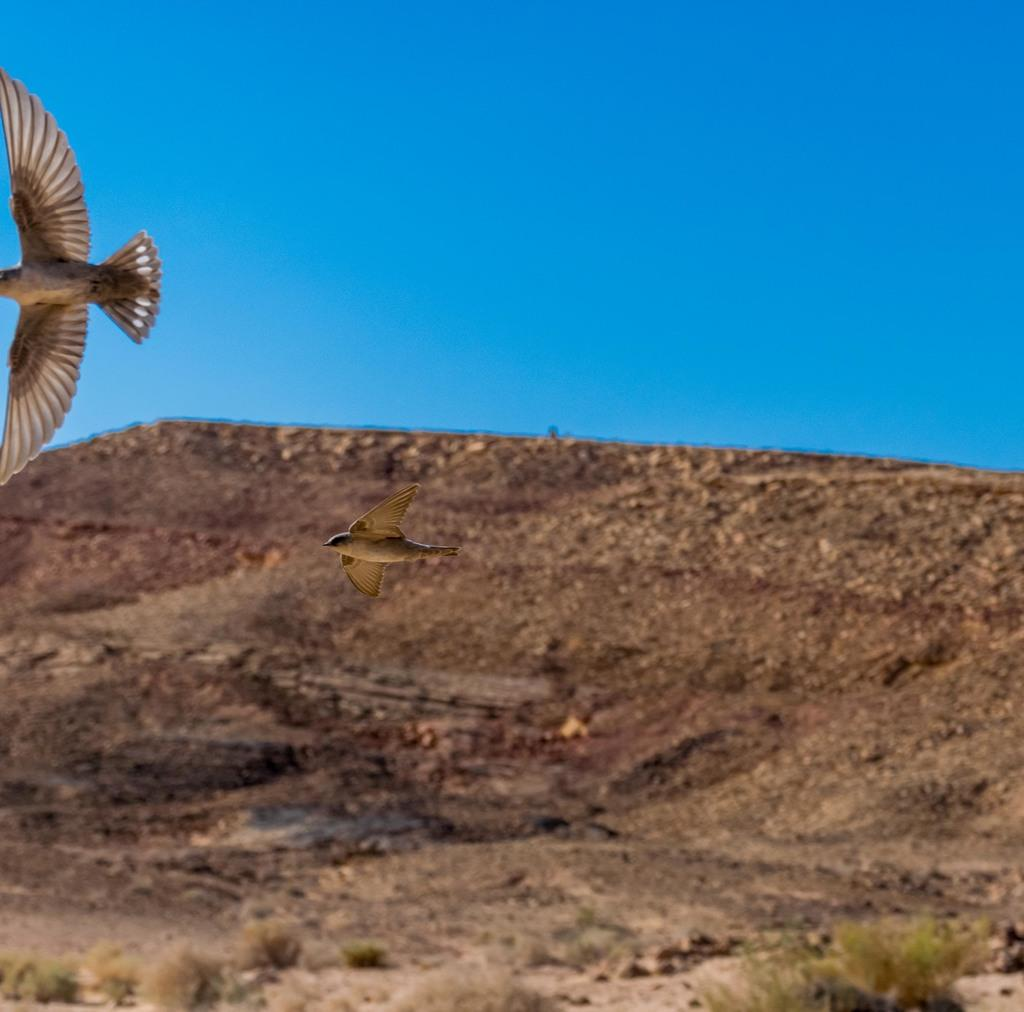What type of animals can be seen in the image? There are birds visible in the image. Where are the birds located in relation to the ground? The birds are above the ground. What is visible at the top of the image? There is a sky at the top of the image. What type of cherry is being worn by the birds in the image? There are no cherries or clothing items present in the image; the birds are simply flying above the ground. 